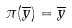Convert formula to latex. <formula><loc_0><loc_0><loc_500><loc_500>\pi ( \overline { y } ) = \overline { y }</formula> 